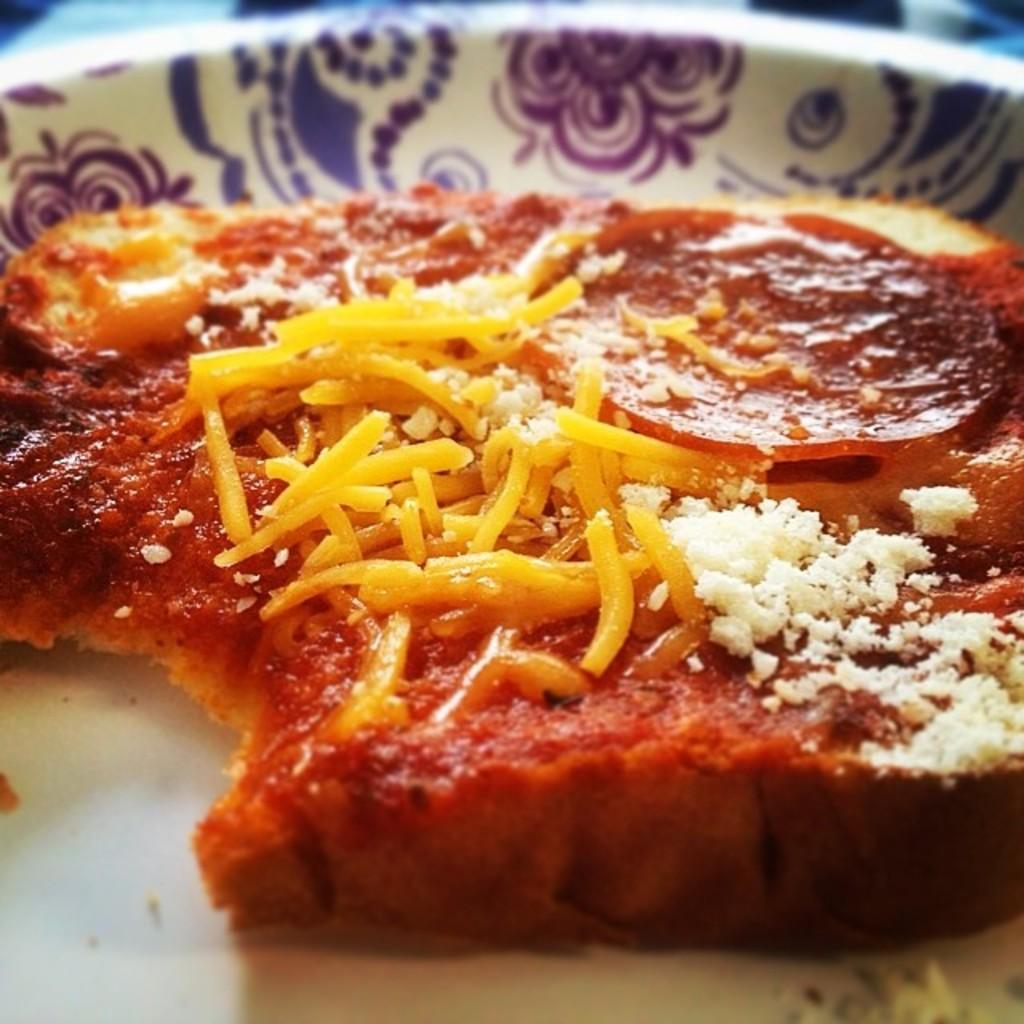What is the main subject in the center of the image? There is a white object in the center of the image. What can be found inside the white object? The white object contains food items. Can you describe any other objects visible in the background of the image? There are other objects visible in the background of the image, but their specific details are not mentioned in the provided facts. Is there any blood visible on the food items in the image? No, there is no blood visible on the food items in the image. Can you see any steam coming from the food items in the image? No, there is no steam visible on the food items in the image. 